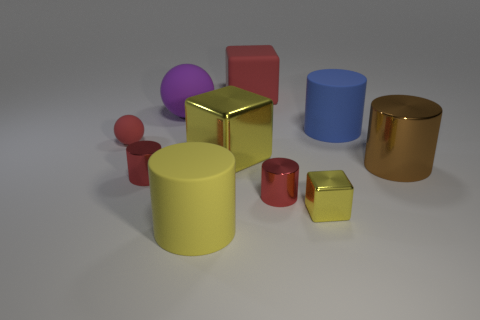There is a ball that is the same color as the large rubber cube; what material is it?
Offer a terse response. Rubber. Are there fewer tiny matte things than brown rubber things?
Your answer should be compact. No. There is another yellow cube that is the same size as the rubber block; what material is it?
Ensure brevity in your answer.  Metal. What number of things are big gray matte blocks or blue rubber cylinders?
Ensure brevity in your answer.  1. How many metal things are both in front of the big yellow shiny block and left of the big brown metallic cylinder?
Your answer should be very brief. 3. Is the number of rubber cylinders that are behind the large yellow metal block less than the number of small red cylinders?
Make the answer very short. Yes. What shape is the purple rubber thing that is the same size as the yellow matte object?
Your answer should be very brief. Sphere. How many other objects are there of the same color as the large rubber sphere?
Your response must be concise. 0. Is the size of the purple thing the same as the blue matte cylinder?
Make the answer very short. Yes. What number of things are either purple rubber spheres or matte things in front of the big blue cylinder?
Give a very brief answer. 3. 